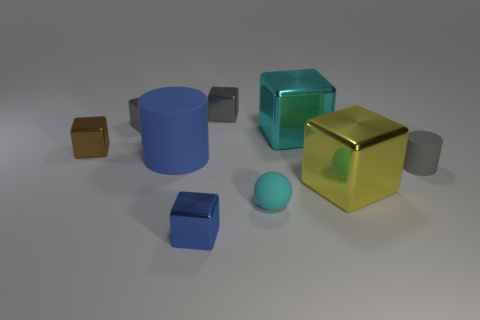Subtract 3 blocks. How many blocks are left? 3 Subtract all blue shiny cubes. How many cubes are left? 5 Subtract all gray blocks. How many blocks are left? 4 Subtract all brown cubes. Subtract all yellow cylinders. How many cubes are left? 5 Add 1 cyan spheres. How many objects exist? 10 Subtract all blocks. How many objects are left? 3 Subtract 1 cyan spheres. How many objects are left? 8 Subtract all big blue cylinders. Subtract all small blue metal blocks. How many objects are left? 7 Add 7 brown shiny cubes. How many brown shiny cubes are left? 8 Add 4 small things. How many small things exist? 10 